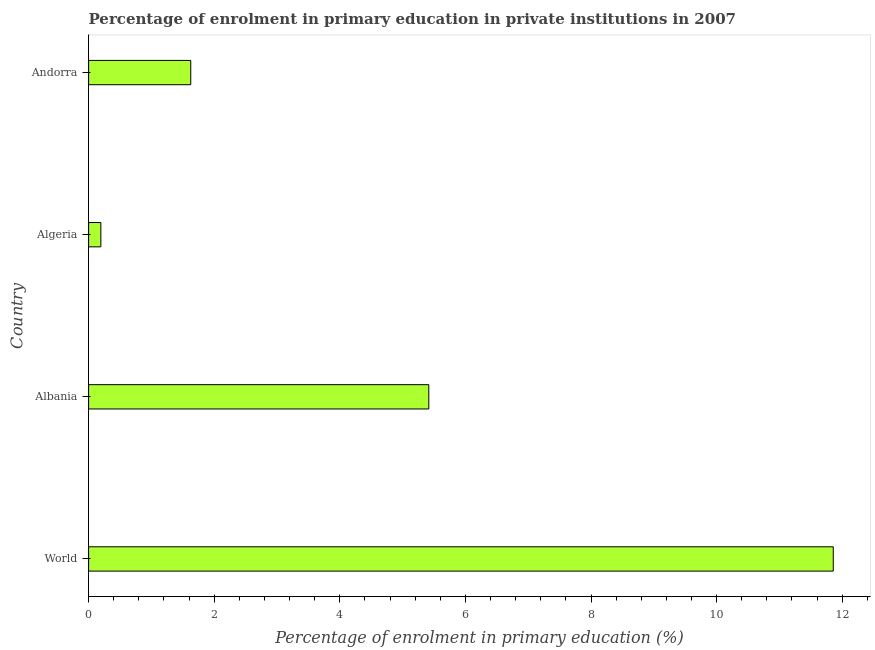Does the graph contain any zero values?
Your answer should be compact. No. Does the graph contain grids?
Offer a very short reply. No. What is the title of the graph?
Offer a very short reply. Percentage of enrolment in primary education in private institutions in 2007. What is the label or title of the X-axis?
Ensure brevity in your answer.  Percentage of enrolment in primary education (%). What is the label or title of the Y-axis?
Make the answer very short. Country. What is the enrolment percentage in primary education in Algeria?
Ensure brevity in your answer.  0.2. Across all countries, what is the maximum enrolment percentage in primary education?
Ensure brevity in your answer.  11.86. Across all countries, what is the minimum enrolment percentage in primary education?
Your answer should be very brief. 0.2. In which country was the enrolment percentage in primary education minimum?
Your response must be concise. Algeria. What is the sum of the enrolment percentage in primary education?
Offer a terse response. 19.1. What is the difference between the enrolment percentage in primary education in Albania and Algeria?
Offer a terse response. 5.22. What is the average enrolment percentage in primary education per country?
Ensure brevity in your answer.  4.77. What is the median enrolment percentage in primary education?
Keep it short and to the point. 3.52. What is the ratio of the enrolment percentage in primary education in Albania to that in Andorra?
Ensure brevity in your answer.  3.33. Is the enrolment percentage in primary education in Algeria less than that in World?
Provide a short and direct response. Yes. What is the difference between the highest and the second highest enrolment percentage in primary education?
Offer a very short reply. 6.44. Is the sum of the enrolment percentage in primary education in Albania and Andorra greater than the maximum enrolment percentage in primary education across all countries?
Your answer should be compact. No. What is the difference between the highest and the lowest enrolment percentage in primary education?
Your answer should be compact. 11.66. How many countries are there in the graph?
Keep it short and to the point. 4. Are the values on the major ticks of X-axis written in scientific E-notation?
Make the answer very short. No. What is the Percentage of enrolment in primary education (%) of World?
Make the answer very short. 11.86. What is the Percentage of enrolment in primary education (%) in Albania?
Give a very brief answer. 5.42. What is the Percentage of enrolment in primary education (%) of Algeria?
Give a very brief answer. 0.2. What is the Percentage of enrolment in primary education (%) of Andorra?
Ensure brevity in your answer.  1.63. What is the difference between the Percentage of enrolment in primary education (%) in World and Albania?
Provide a succinct answer. 6.44. What is the difference between the Percentage of enrolment in primary education (%) in World and Algeria?
Provide a succinct answer. 11.66. What is the difference between the Percentage of enrolment in primary education (%) in World and Andorra?
Offer a very short reply. 10.23. What is the difference between the Percentage of enrolment in primary education (%) in Albania and Algeria?
Keep it short and to the point. 5.22. What is the difference between the Percentage of enrolment in primary education (%) in Albania and Andorra?
Keep it short and to the point. 3.79. What is the difference between the Percentage of enrolment in primary education (%) in Algeria and Andorra?
Provide a short and direct response. -1.43. What is the ratio of the Percentage of enrolment in primary education (%) in World to that in Albania?
Your answer should be very brief. 2.19. What is the ratio of the Percentage of enrolment in primary education (%) in World to that in Algeria?
Offer a very short reply. 60.79. What is the ratio of the Percentage of enrolment in primary education (%) in World to that in Andorra?
Offer a terse response. 7.29. What is the ratio of the Percentage of enrolment in primary education (%) in Albania to that in Algeria?
Ensure brevity in your answer.  27.77. What is the ratio of the Percentage of enrolment in primary education (%) in Albania to that in Andorra?
Your answer should be compact. 3.33. What is the ratio of the Percentage of enrolment in primary education (%) in Algeria to that in Andorra?
Keep it short and to the point. 0.12. 